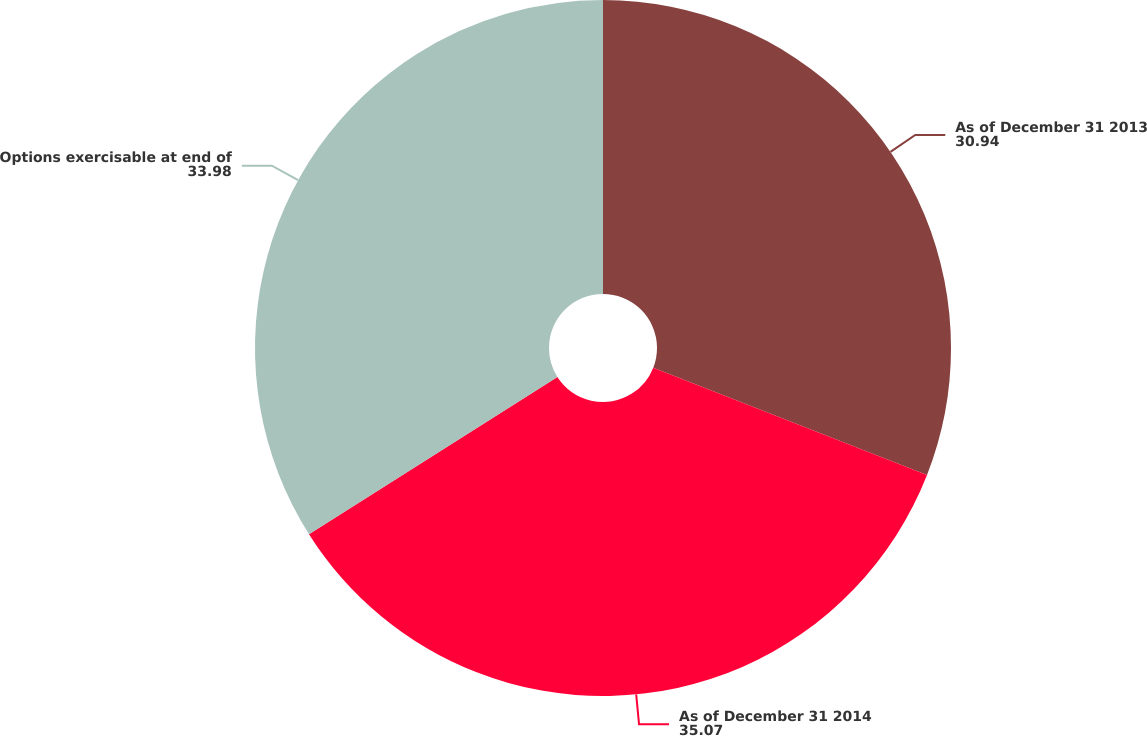Convert chart. <chart><loc_0><loc_0><loc_500><loc_500><pie_chart><fcel>As of December 31 2013<fcel>As of December 31 2014<fcel>Options exercisable at end of<nl><fcel>30.94%<fcel>35.07%<fcel>33.98%<nl></chart> 